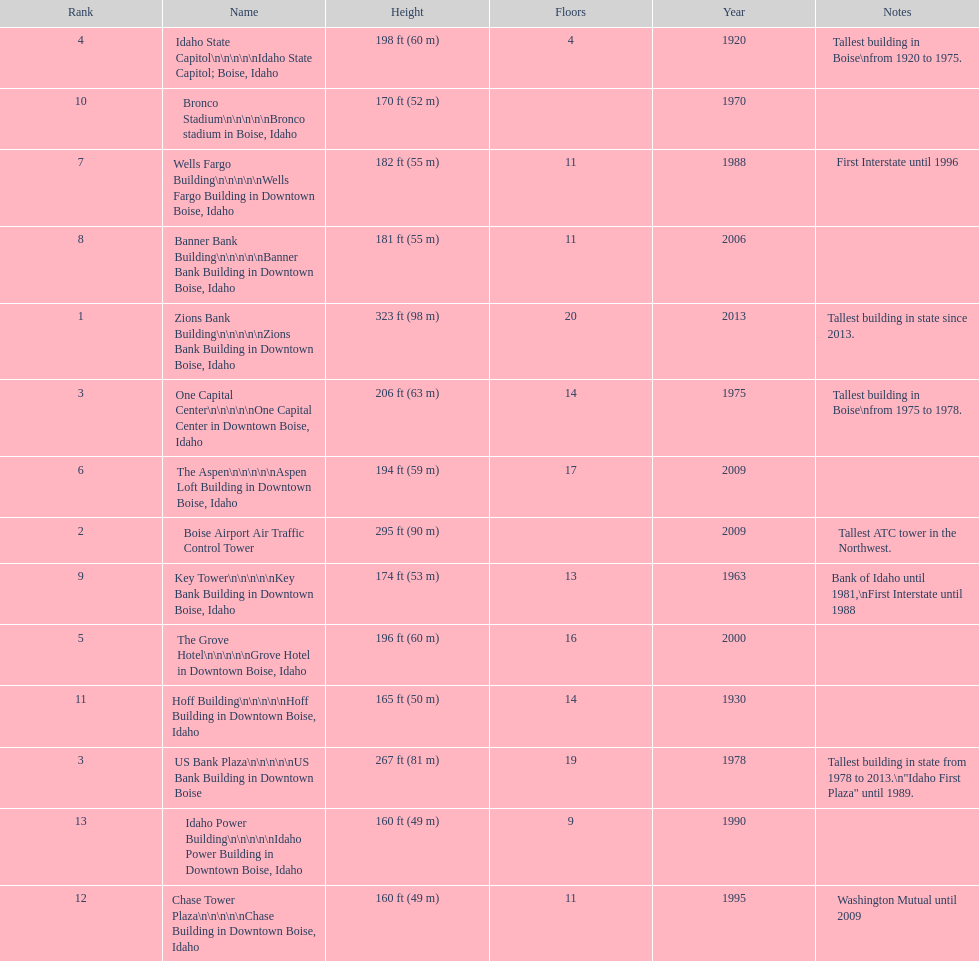How tall (in meters) is the tallest building? 98 m. 